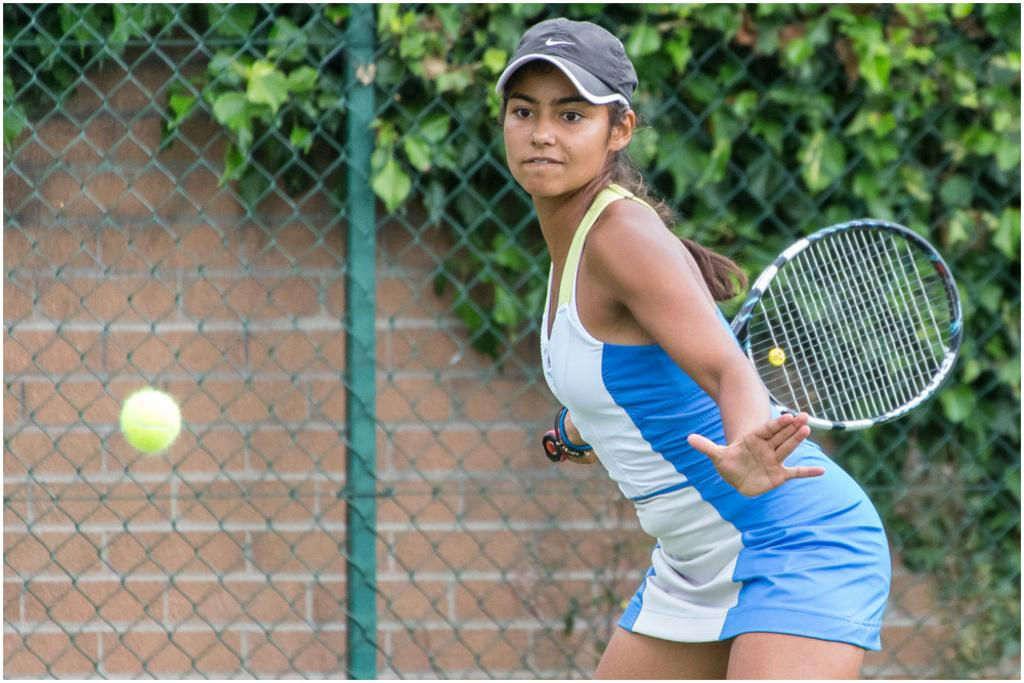Who is the main subject in the image? There is a lady in the image. What is the lady holding in the image? The lady is holding a tennis racket. What other tennis-related item can be seen in the image? There is a tennis ball in the image. What type of architectural feature is present in the image? There is fencing in the image. What type of natural elements are present in the image? There are plants in the image. What type of button is the lady wearing on her shirt in the image? There is no button visible on the lady's shirt in the image. What type of metal is used to construct the tennis racket in the image? The image does not provide information about the materials used to construct the tennis racket. 